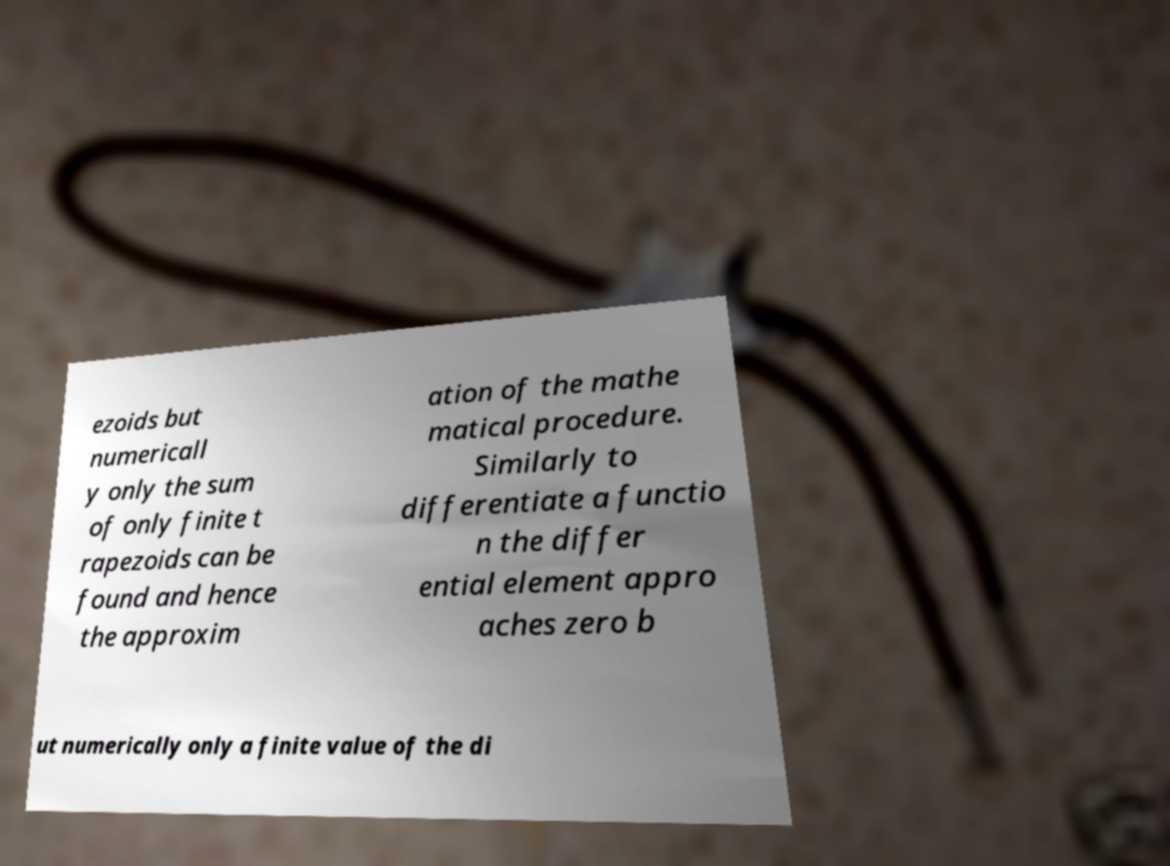Can you accurately transcribe the text from the provided image for me? ezoids but numericall y only the sum of only finite t rapezoids can be found and hence the approxim ation of the mathe matical procedure. Similarly to differentiate a functio n the differ ential element appro aches zero b ut numerically only a finite value of the di 